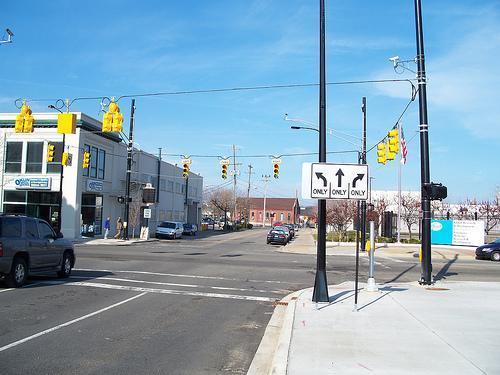How many traffic lights are in the photo?
Give a very brief answer. 11. How many black and white traffic signs are in the photo?
Give a very brief answer. 1. 